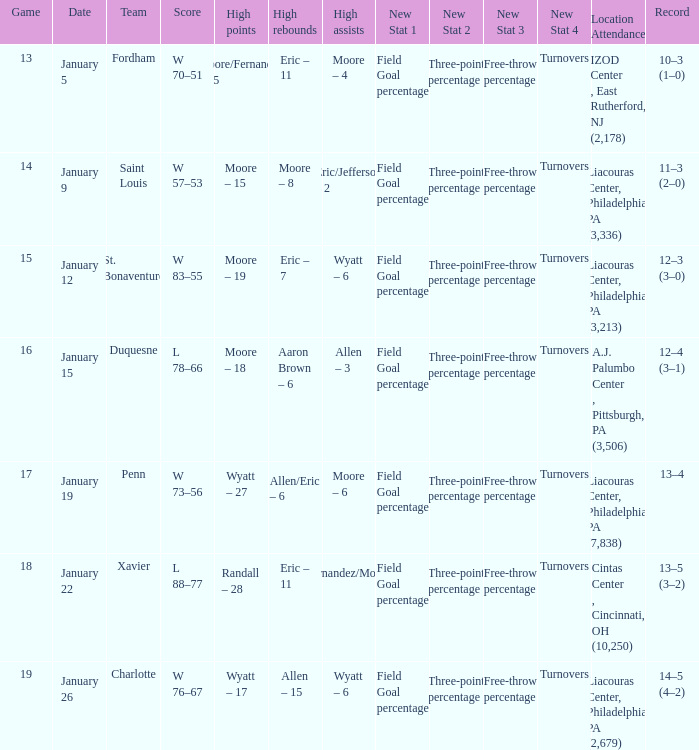Who had the most assists and how many did they have on January 5? Moore – 4. 